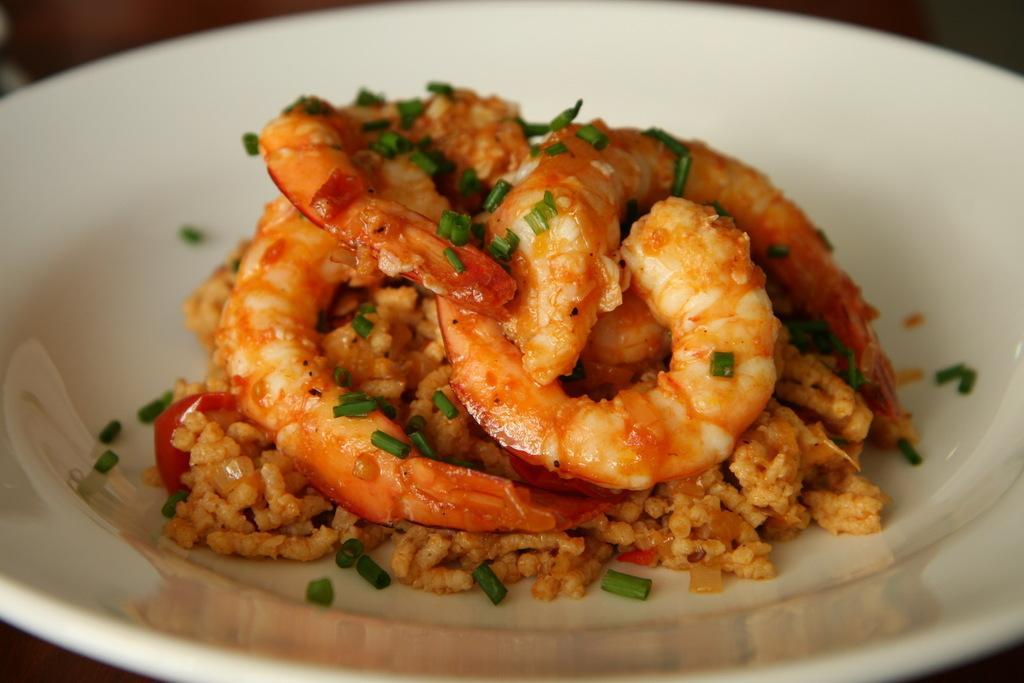Could you give a brief overview of what you see in this image? This image consists of a plate in which food items are there. This image is taken may be in a room. 